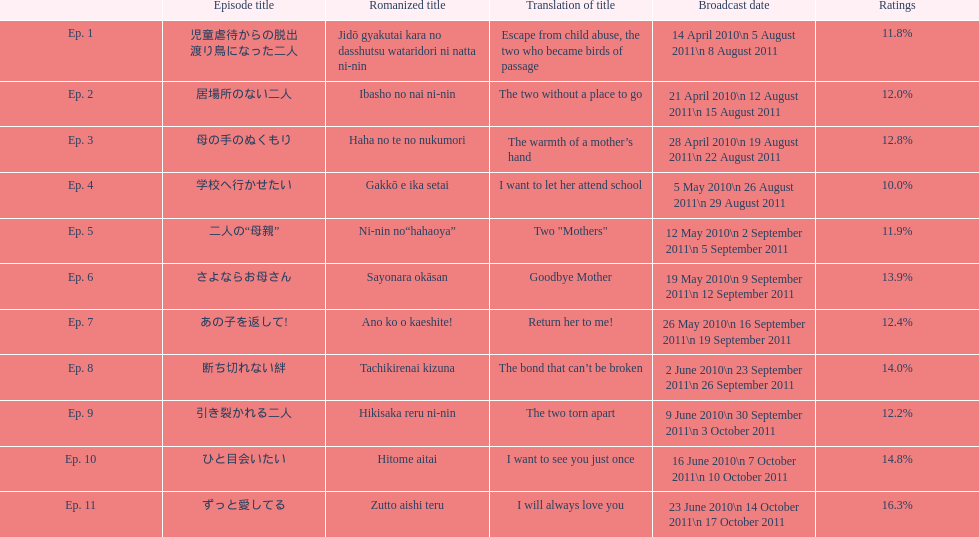What episode number was the only episode to have over 16% of ratings? 11. 